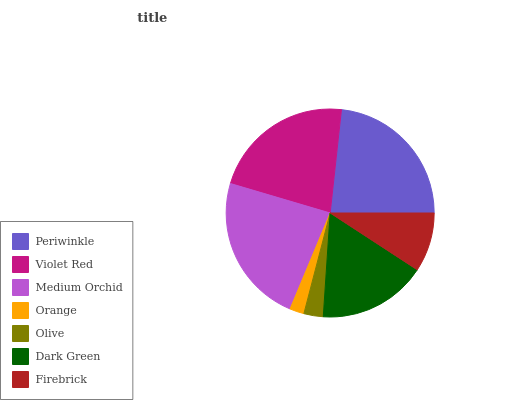Is Orange the minimum?
Answer yes or no. Yes. Is Medium Orchid the maximum?
Answer yes or no. Yes. Is Violet Red the minimum?
Answer yes or no. No. Is Violet Red the maximum?
Answer yes or no. No. Is Periwinkle greater than Violet Red?
Answer yes or no. Yes. Is Violet Red less than Periwinkle?
Answer yes or no. Yes. Is Violet Red greater than Periwinkle?
Answer yes or no. No. Is Periwinkle less than Violet Red?
Answer yes or no. No. Is Dark Green the high median?
Answer yes or no. Yes. Is Dark Green the low median?
Answer yes or no. Yes. Is Firebrick the high median?
Answer yes or no. No. Is Firebrick the low median?
Answer yes or no. No. 